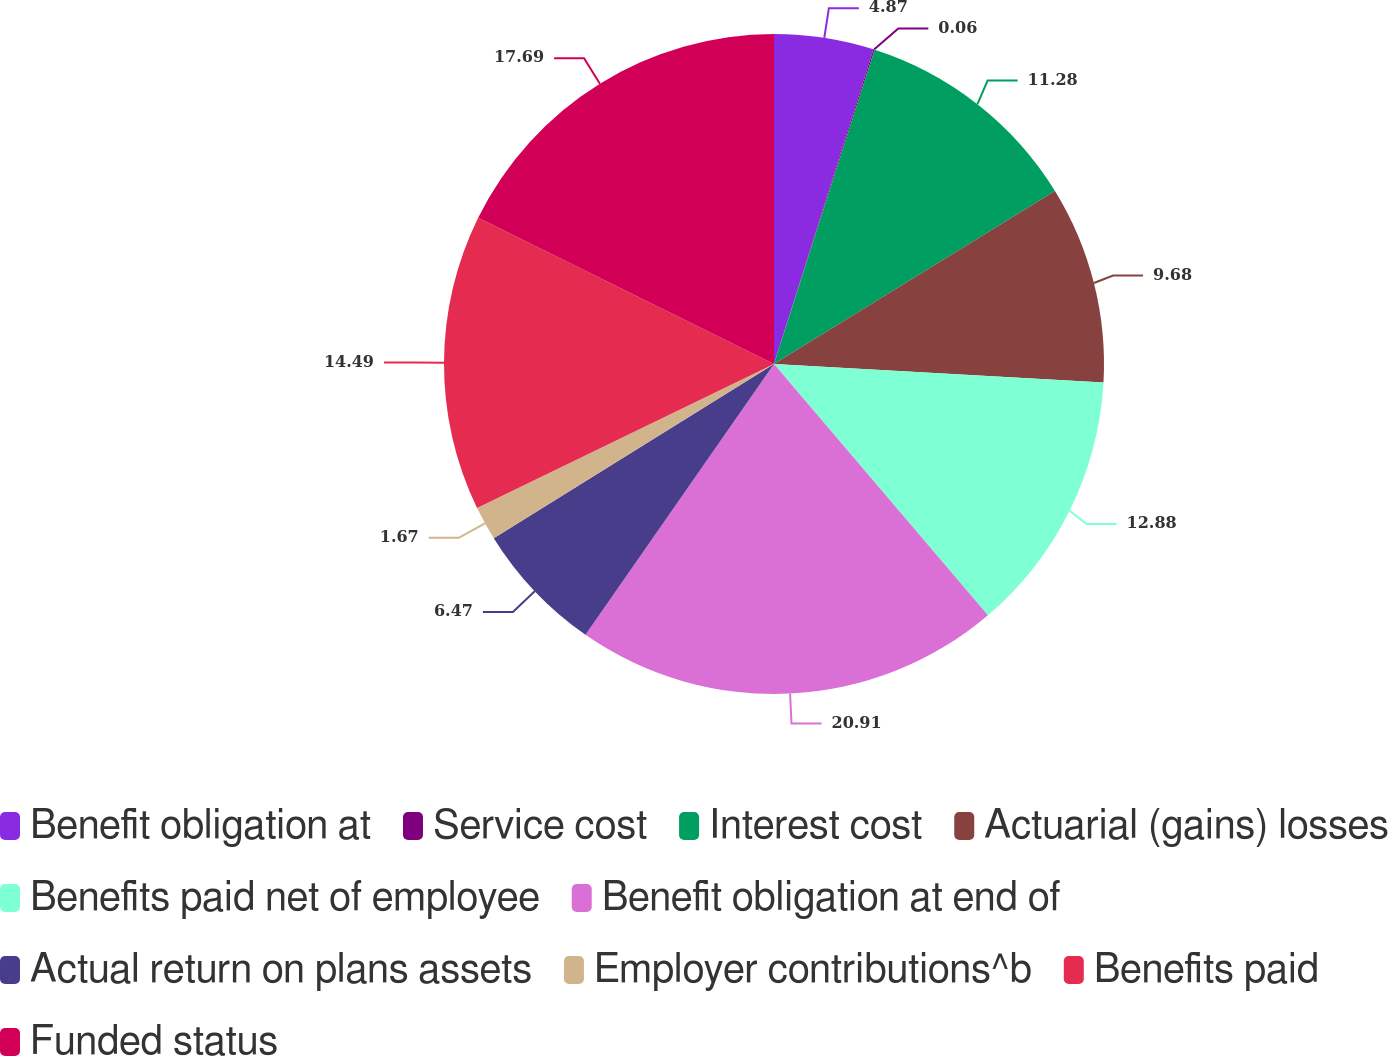Convert chart to OTSL. <chart><loc_0><loc_0><loc_500><loc_500><pie_chart><fcel>Benefit obligation at<fcel>Service cost<fcel>Interest cost<fcel>Actuarial (gains) losses<fcel>Benefits paid net of employee<fcel>Benefit obligation at end of<fcel>Actual return on plans assets<fcel>Employer contributions^b<fcel>Benefits paid<fcel>Funded status<nl><fcel>4.87%<fcel>0.06%<fcel>11.28%<fcel>9.68%<fcel>12.88%<fcel>20.9%<fcel>6.47%<fcel>1.67%<fcel>14.49%<fcel>17.69%<nl></chart> 